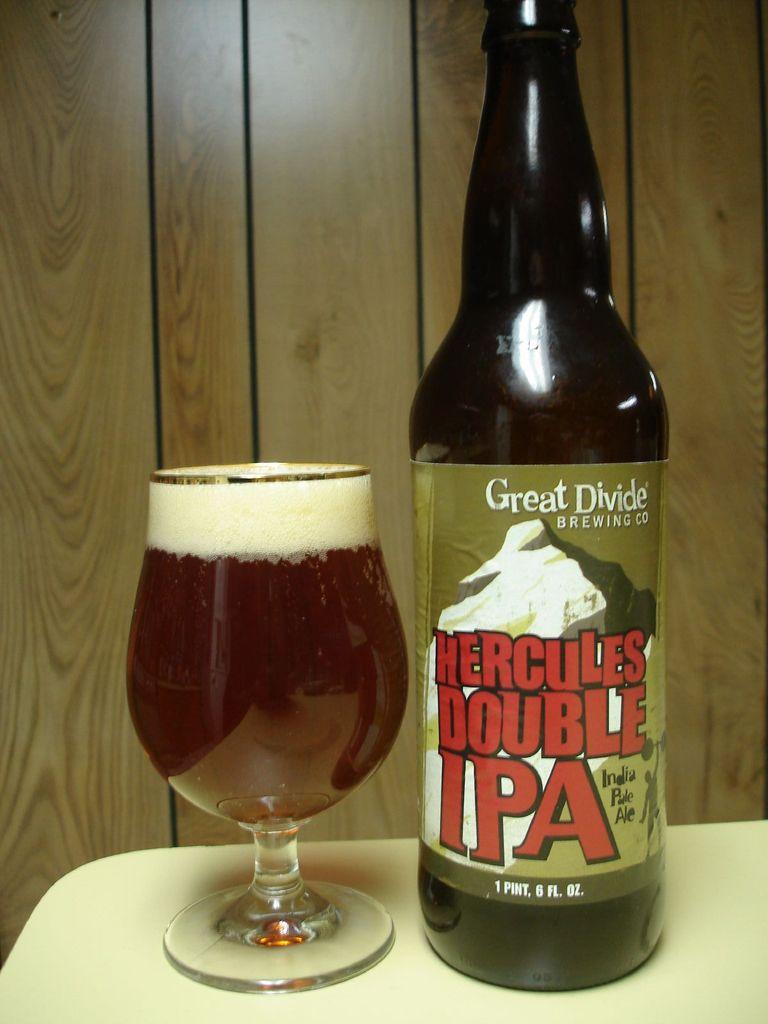Which brewery did this come from?
Your answer should be very brief. Great divide. What brand of beer on the right?
Make the answer very short. Great divide. 